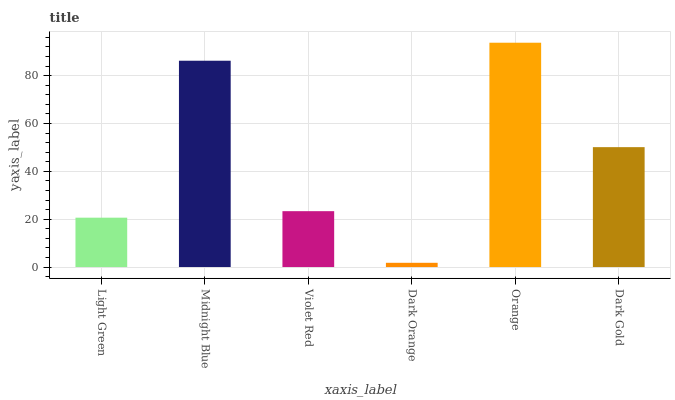Is Dark Orange the minimum?
Answer yes or no. Yes. Is Orange the maximum?
Answer yes or no. Yes. Is Midnight Blue the minimum?
Answer yes or no. No. Is Midnight Blue the maximum?
Answer yes or no. No. Is Midnight Blue greater than Light Green?
Answer yes or no. Yes. Is Light Green less than Midnight Blue?
Answer yes or no. Yes. Is Light Green greater than Midnight Blue?
Answer yes or no. No. Is Midnight Blue less than Light Green?
Answer yes or no. No. Is Dark Gold the high median?
Answer yes or no. Yes. Is Violet Red the low median?
Answer yes or no. Yes. Is Violet Red the high median?
Answer yes or no. No. Is Dark Orange the low median?
Answer yes or no. No. 